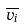<formula> <loc_0><loc_0><loc_500><loc_500>\overline { v _ { i } }</formula> 